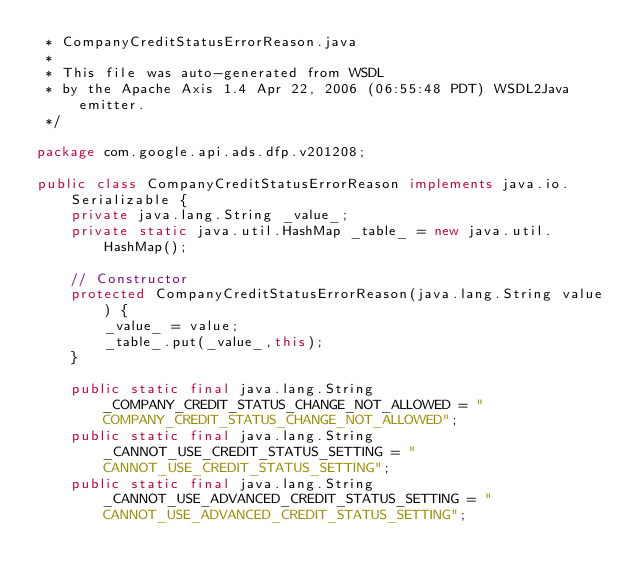Convert code to text. <code><loc_0><loc_0><loc_500><loc_500><_Java_> * CompanyCreditStatusErrorReason.java
 *
 * This file was auto-generated from WSDL
 * by the Apache Axis 1.4 Apr 22, 2006 (06:55:48 PDT) WSDL2Java emitter.
 */

package com.google.api.ads.dfp.v201208;

public class CompanyCreditStatusErrorReason implements java.io.Serializable {
    private java.lang.String _value_;
    private static java.util.HashMap _table_ = new java.util.HashMap();

    // Constructor
    protected CompanyCreditStatusErrorReason(java.lang.String value) {
        _value_ = value;
        _table_.put(_value_,this);
    }

    public static final java.lang.String _COMPANY_CREDIT_STATUS_CHANGE_NOT_ALLOWED = "COMPANY_CREDIT_STATUS_CHANGE_NOT_ALLOWED";
    public static final java.lang.String _CANNOT_USE_CREDIT_STATUS_SETTING = "CANNOT_USE_CREDIT_STATUS_SETTING";
    public static final java.lang.String _CANNOT_USE_ADVANCED_CREDIT_STATUS_SETTING = "CANNOT_USE_ADVANCED_CREDIT_STATUS_SETTING";</code> 